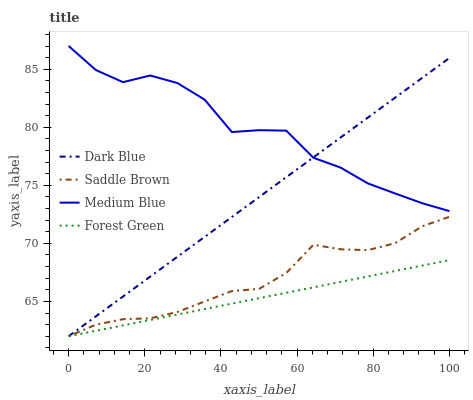Does Forest Green have the minimum area under the curve?
Answer yes or no. Yes. Does Medium Blue have the maximum area under the curve?
Answer yes or no. Yes. Does Medium Blue have the minimum area under the curve?
Answer yes or no. No. Does Forest Green have the maximum area under the curve?
Answer yes or no. No. Is Forest Green the smoothest?
Answer yes or no. Yes. Is Medium Blue the roughest?
Answer yes or no. Yes. Is Medium Blue the smoothest?
Answer yes or no. No. Is Forest Green the roughest?
Answer yes or no. No. Does Dark Blue have the lowest value?
Answer yes or no. Yes. Does Medium Blue have the lowest value?
Answer yes or no. No. Does Medium Blue have the highest value?
Answer yes or no. Yes. Does Forest Green have the highest value?
Answer yes or no. No. Is Forest Green less than Medium Blue?
Answer yes or no. Yes. Is Medium Blue greater than Forest Green?
Answer yes or no. Yes. Does Forest Green intersect Dark Blue?
Answer yes or no. Yes. Is Forest Green less than Dark Blue?
Answer yes or no. No. Is Forest Green greater than Dark Blue?
Answer yes or no. No. Does Forest Green intersect Medium Blue?
Answer yes or no. No. 